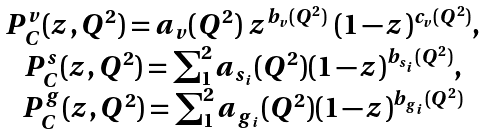Convert formula to latex. <formula><loc_0><loc_0><loc_500><loc_500>\begin{array} { c } P _ { C } ^ { v } ( z , Q ^ { 2 } ) = a _ { v } ( Q ^ { 2 } ) \ z ^ { b _ { v } ( Q ^ { 2 } ) } \ ( 1 - z ) ^ { c _ { v } ( Q ^ { 2 } ) } , \\ P _ { C } ^ { s } ( z , Q ^ { 2 } ) = \sum _ { 1 } ^ { 2 } a _ { s _ { i } } ( Q ^ { 2 } ) ( 1 - z ) ^ { b _ { s _ { i } } ( Q ^ { 2 } ) } , \\ P _ { C } ^ { g } ( z , Q ^ { 2 } ) = \sum _ { 1 } ^ { 2 } a _ { g _ { i } } ( Q ^ { 2 } ) ( 1 - z ) ^ { b _ { g _ { i } } ( Q ^ { 2 } ) } \end{array}</formula> 